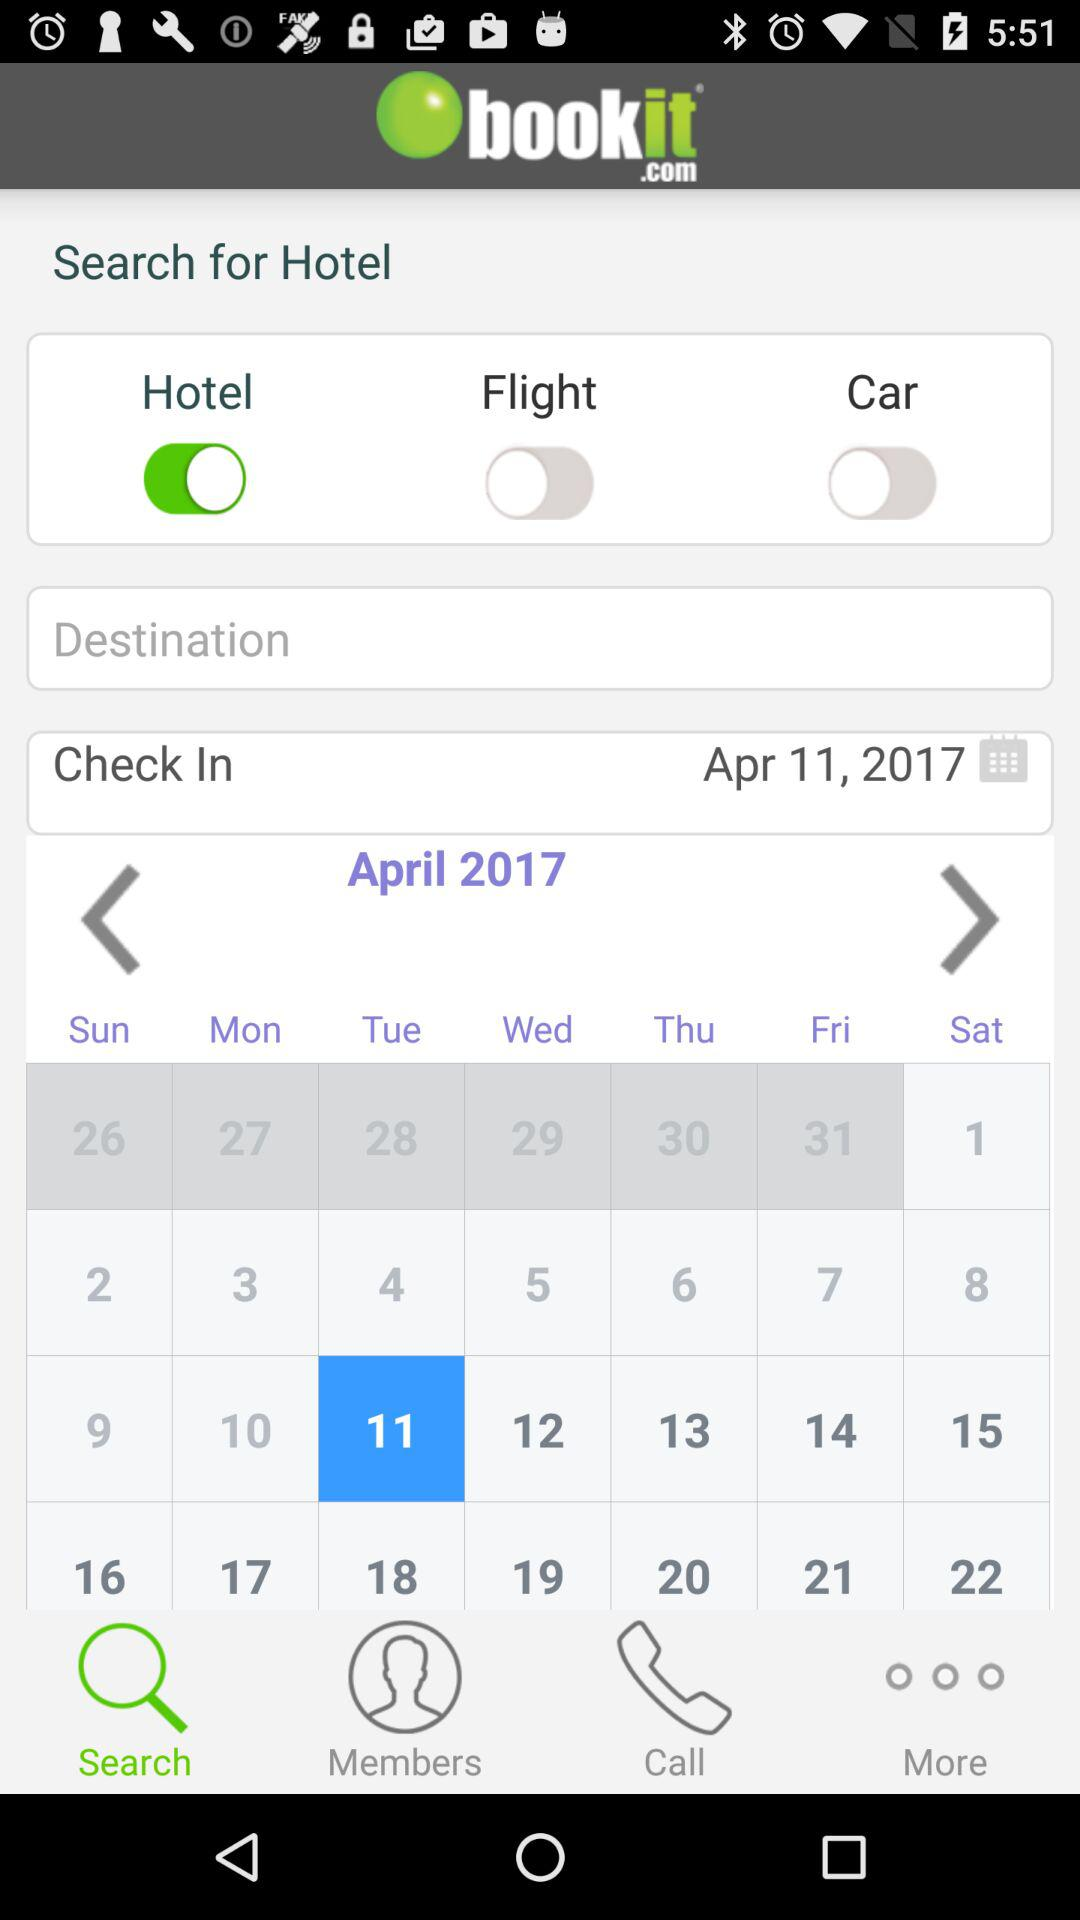What is the current state of "Car"? The current status of "Car" is "off". 